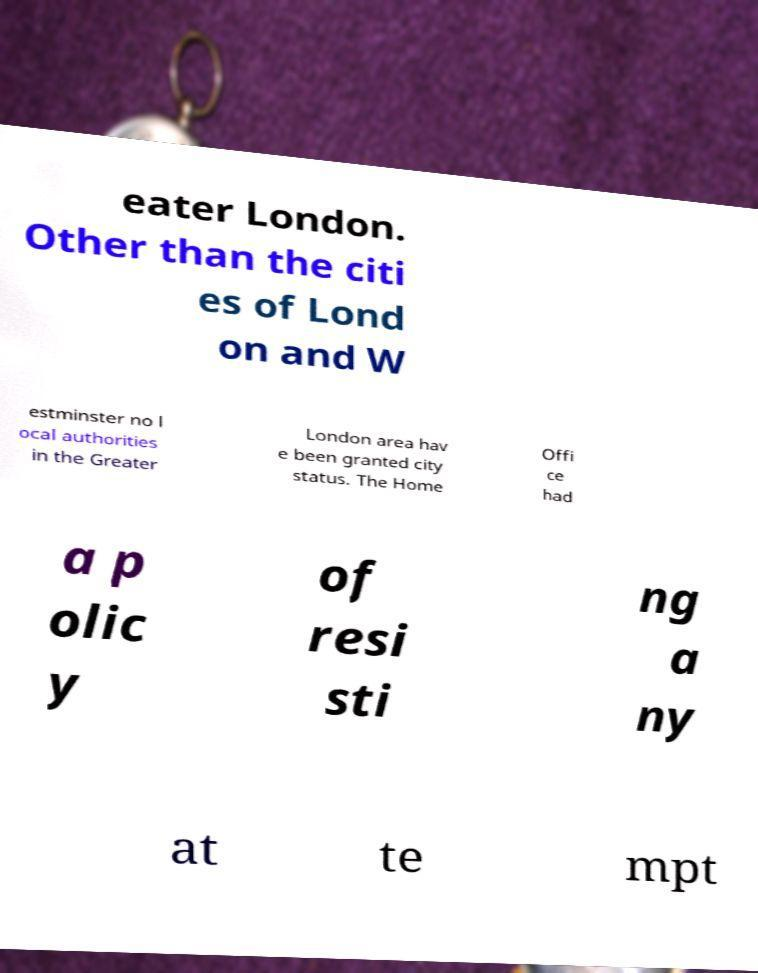Could you assist in decoding the text presented in this image and type it out clearly? eater London. Other than the citi es of Lond on and W estminster no l ocal authorities in the Greater London area hav e been granted city status. The Home Offi ce had a p olic y of resi sti ng a ny at te mpt 